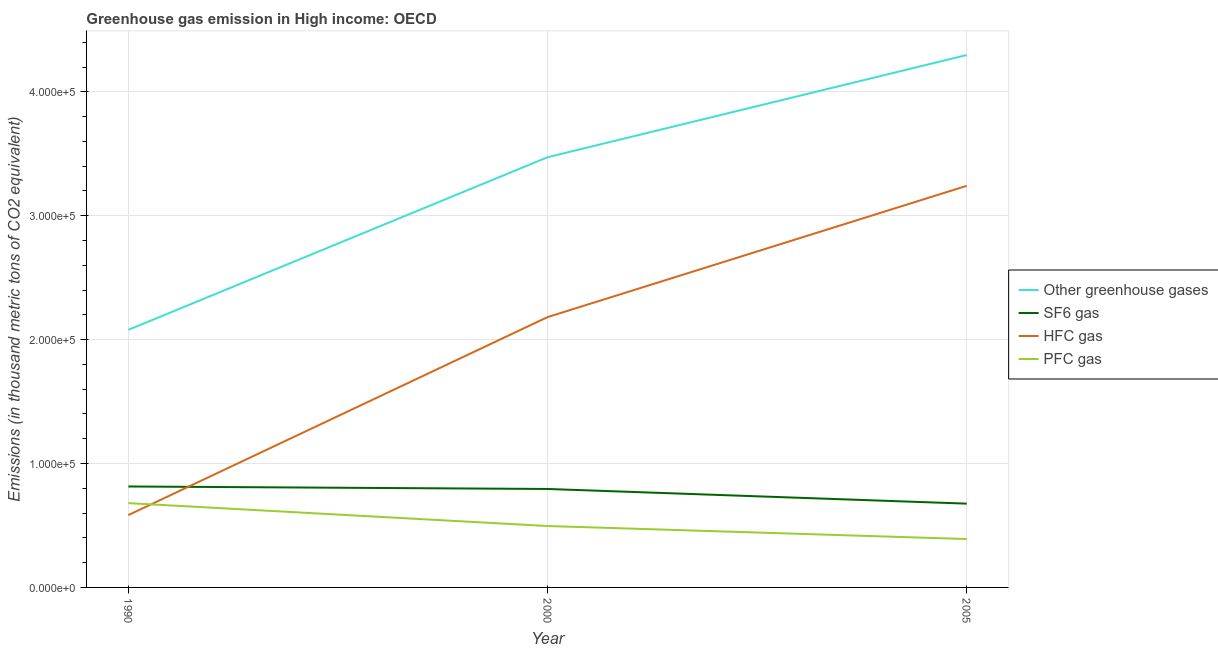What is the emission of hfc gas in 2000?
Your response must be concise. 2.18e+05. Across all years, what is the maximum emission of greenhouse gases?
Offer a terse response. 4.30e+05. Across all years, what is the minimum emission of greenhouse gases?
Provide a succinct answer. 2.08e+05. In which year was the emission of sf6 gas maximum?
Your answer should be compact. 1990. In which year was the emission of hfc gas minimum?
Offer a terse response. 1990. What is the total emission of pfc gas in the graph?
Your answer should be very brief. 1.57e+05. What is the difference between the emission of pfc gas in 1990 and that in 2005?
Your response must be concise. 2.90e+04. What is the difference between the emission of pfc gas in 2000 and the emission of sf6 gas in 2005?
Offer a terse response. -1.80e+04. What is the average emission of sf6 gas per year?
Make the answer very short. 7.62e+04. In the year 2005, what is the difference between the emission of sf6 gas and emission of hfc gas?
Keep it short and to the point. -2.57e+05. In how many years, is the emission of sf6 gas greater than 260000 thousand metric tons?
Offer a very short reply. 0. What is the ratio of the emission of greenhouse gases in 1990 to that in 2000?
Give a very brief answer. 0.6. Is the emission of hfc gas in 1990 less than that in 2000?
Keep it short and to the point. Yes. What is the difference between the highest and the second highest emission of greenhouse gases?
Make the answer very short. 8.25e+04. What is the difference between the highest and the lowest emission of pfc gas?
Offer a very short reply. 2.90e+04. Is the sum of the emission of greenhouse gases in 2000 and 2005 greater than the maximum emission of sf6 gas across all years?
Ensure brevity in your answer.  Yes. Is it the case that in every year, the sum of the emission of greenhouse gases and emission of sf6 gas is greater than the emission of hfc gas?
Offer a terse response. Yes. Does the emission of pfc gas monotonically increase over the years?
Make the answer very short. No. Is the emission of sf6 gas strictly greater than the emission of pfc gas over the years?
Your answer should be compact. Yes. How many lines are there?
Your answer should be compact. 4. How many years are there in the graph?
Provide a short and direct response. 3. What is the difference between two consecutive major ticks on the Y-axis?
Give a very brief answer. 1.00e+05. Are the values on the major ticks of Y-axis written in scientific E-notation?
Your answer should be compact. Yes. Where does the legend appear in the graph?
Provide a succinct answer. Center right. How many legend labels are there?
Provide a short and direct response. 4. What is the title of the graph?
Your response must be concise. Greenhouse gas emission in High income: OECD. Does "Financial sector" appear as one of the legend labels in the graph?
Give a very brief answer. No. What is the label or title of the X-axis?
Your response must be concise. Year. What is the label or title of the Y-axis?
Your answer should be compact. Emissions (in thousand metric tons of CO2 equivalent). What is the Emissions (in thousand metric tons of CO2 equivalent) in Other greenhouse gases in 1990?
Your response must be concise. 2.08e+05. What is the Emissions (in thousand metric tons of CO2 equivalent) of SF6 gas in 1990?
Keep it short and to the point. 8.15e+04. What is the Emissions (in thousand metric tons of CO2 equivalent) of HFC gas in 1990?
Offer a very short reply. 5.84e+04. What is the Emissions (in thousand metric tons of CO2 equivalent) of PFC gas in 1990?
Give a very brief answer. 6.80e+04. What is the Emissions (in thousand metric tons of CO2 equivalent) in Other greenhouse gases in 2000?
Make the answer very short. 3.47e+05. What is the Emissions (in thousand metric tons of CO2 equivalent) in SF6 gas in 2000?
Your response must be concise. 7.95e+04. What is the Emissions (in thousand metric tons of CO2 equivalent) in HFC gas in 2000?
Provide a short and direct response. 2.18e+05. What is the Emissions (in thousand metric tons of CO2 equivalent) in PFC gas in 2000?
Ensure brevity in your answer.  4.96e+04. What is the Emissions (in thousand metric tons of CO2 equivalent) in Other greenhouse gases in 2005?
Keep it short and to the point. 4.30e+05. What is the Emissions (in thousand metric tons of CO2 equivalent) in SF6 gas in 2005?
Provide a succinct answer. 6.76e+04. What is the Emissions (in thousand metric tons of CO2 equivalent) of HFC gas in 2005?
Make the answer very short. 3.24e+05. What is the Emissions (in thousand metric tons of CO2 equivalent) of PFC gas in 2005?
Provide a short and direct response. 3.91e+04. Across all years, what is the maximum Emissions (in thousand metric tons of CO2 equivalent) in Other greenhouse gases?
Your answer should be very brief. 4.30e+05. Across all years, what is the maximum Emissions (in thousand metric tons of CO2 equivalent) in SF6 gas?
Provide a succinct answer. 8.15e+04. Across all years, what is the maximum Emissions (in thousand metric tons of CO2 equivalent) in HFC gas?
Your response must be concise. 3.24e+05. Across all years, what is the maximum Emissions (in thousand metric tons of CO2 equivalent) in PFC gas?
Offer a very short reply. 6.80e+04. Across all years, what is the minimum Emissions (in thousand metric tons of CO2 equivalent) in Other greenhouse gases?
Offer a terse response. 2.08e+05. Across all years, what is the minimum Emissions (in thousand metric tons of CO2 equivalent) of SF6 gas?
Keep it short and to the point. 6.76e+04. Across all years, what is the minimum Emissions (in thousand metric tons of CO2 equivalent) of HFC gas?
Provide a short and direct response. 5.84e+04. Across all years, what is the minimum Emissions (in thousand metric tons of CO2 equivalent) in PFC gas?
Ensure brevity in your answer.  3.91e+04. What is the total Emissions (in thousand metric tons of CO2 equivalent) of Other greenhouse gases in the graph?
Provide a short and direct response. 9.85e+05. What is the total Emissions (in thousand metric tons of CO2 equivalent) of SF6 gas in the graph?
Offer a very short reply. 2.29e+05. What is the total Emissions (in thousand metric tons of CO2 equivalent) of HFC gas in the graph?
Your answer should be very brief. 6.01e+05. What is the total Emissions (in thousand metric tons of CO2 equivalent) of PFC gas in the graph?
Provide a short and direct response. 1.57e+05. What is the difference between the Emissions (in thousand metric tons of CO2 equivalent) of Other greenhouse gases in 1990 and that in 2000?
Offer a terse response. -1.39e+05. What is the difference between the Emissions (in thousand metric tons of CO2 equivalent) in SF6 gas in 1990 and that in 2000?
Provide a short and direct response. 2011.1. What is the difference between the Emissions (in thousand metric tons of CO2 equivalent) in HFC gas in 1990 and that in 2000?
Offer a terse response. -1.60e+05. What is the difference between the Emissions (in thousand metric tons of CO2 equivalent) of PFC gas in 1990 and that in 2000?
Your answer should be very brief. 1.85e+04. What is the difference between the Emissions (in thousand metric tons of CO2 equivalent) in Other greenhouse gases in 1990 and that in 2005?
Provide a succinct answer. -2.22e+05. What is the difference between the Emissions (in thousand metric tons of CO2 equivalent) of SF6 gas in 1990 and that in 2005?
Offer a terse response. 1.39e+04. What is the difference between the Emissions (in thousand metric tons of CO2 equivalent) of HFC gas in 1990 and that in 2005?
Ensure brevity in your answer.  -2.66e+05. What is the difference between the Emissions (in thousand metric tons of CO2 equivalent) of PFC gas in 1990 and that in 2005?
Offer a very short reply. 2.90e+04. What is the difference between the Emissions (in thousand metric tons of CO2 equivalent) of Other greenhouse gases in 2000 and that in 2005?
Your response must be concise. -8.25e+04. What is the difference between the Emissions (in thousand metric tons of CO2 equivalent) of SF6 gas in 2000 and that in 2005?
Offer a very short reply. 1.18e+04. What is the difference between the Emissions (in thousand metric tons of CO2 equivalent) in HFC gas in 2000 and that in 2005?
Offer a very short reply. -1.06e+05. What is the difference between the Emissions (in thousand metric tons of CO2 equivalent) of PFC gas in 2000 and that in 2005?
Provide a short and direct response. 1.05e+04. What is the difference between the Emissions (in thousand metric tons of CO2 equivalent) of Other greenhouse gases in 1990 and the Emissions (in thousand metric tons of CO2 equivalent) of SF6 gas in 2000?
Ensure brevity in your answer.  1.28e+05. What is the difference between the Emissions (in thousand metric tons of CO2 equivalent) in Other greenhouse gases in 1990 and the Emissions (in thousand metric tons of CO2 equivalent) in HFC gas in 2000?
Your response must be concise. -1.03e+04. What is the difference between the Emissions (in thousand metric tons of CO2 equivalent) in Other greenhouse gases in 1990 and the Emissions (in thousand metric tons of CO2 equivalent) in PFC gas in 2000?
Provide a short and direct response. 1.58e+05. What is the difference between the Emissions (in thousand metric tons of CO2 equivalent) of SF6 gas in 1990 and the Emissions (in thousand metric tons of CO2 equivalent) of HFC gas in 2000?
Provide a short and direct response. -1.37e+05. What is the difference between the Emissions (in thousand metric tons of CO2 equivalent) in SF6 gas in 1990 and the Emissions (in thousand metric tons of CO2 equivalent) in PFC gas in 2000?
Provide a succinct answer. 3.19e+04. What is the difference between the Emissions (in thousand metric tons of CO2 equivalent) of HFC gas in 1990 and the Emissions (in thousand metric tons of CO2 equivalent) of PFC gas in 2000?
Give a very brief answer. 8816.3. What is the difference between the Emissions (in thousand metric tons of CO2 equivalent) in Other greenhouse gases in 1990 and the Emissions (in thousand metric tons of CO2 equivalent) in SF6 gas in 2005?
Provide a succinct answer. 1.40e+05. What is the difference between the Emissions (in thousand metric tons of CO2 equivalent) in Other greenhouse gases in 1990 and the Emissions (in thousand metric tons of CO2 equivalent) in HFC gas in 2005?
Make the answer very short. -1.16e+05. What is the difference between the Emissions (in thousand metric tons of CO2 equivalent) in Other greenhouse gases in 1990 and the Emissions (in thousand metric tons of CO2 equivalent) in PFC gas in 2005?
Offer a very short reply. 1.69e+05. What is the difference between the Emissions (in thousand metric tons of CO2 equivalent) in SF6 gas in 1990 and the Emissions (in thousand metric tons of CO2 equivalent) in HFC gas in 2005?
Give a very brief answer. -2.43e+05. What is the difference between the Emissions (in thousand metric tons of CO2 equivalent) of SF6 gas in 1990 and the Emissions (in thousand metric tons of CO2 equivalent) of PFC gas in 2005?
Make the answer very short. 4.24e+04. What is the difference between the Emissions (in thousand metric tons of CO2 equivalent) in HFC gas in 1990 and the Emissions (in thousand metric tons of CO2 equivalent) in PFC gas in 2005?
Give a very brief answer. 1.93e+04. What is the difference between the Emissions (in thousand metric tons of CO2 equivalent) of Other greenhouse gases in 2000 and the Emissions (in thousand metric tons of CO2 equivalent) of SF6 gas in 2005?
Ensure brevity in your answer.  2.80e+05. What is the difference between the Emissions (in thousand metric tons of CO2 equivalent) of Other greenhouse gases in 2000 and the Emissions (in thousand metric tons of CO2 equivalent) of HFC gas in 2005?
Your answer should be very brief. 2.31e+04. What is the difference between the Emissions (in thousand metric tons of CO2 equivalent) in Other greenhouse gases in 2000 and the Emissions (in thousand metric tons of CO2 equivalent) in PFC gas in 2005?
Your response must be concise. 3.08e+05. What is the difference between the Emissions (in thousand metric tons of CO2 equivalent) in SF6 gas in 2000 and the Emissions (in thousand metric tons of CO2 equivalent) in HFC gas in 2005?
Your answer should be very brief. -2.45e+05. What is the difference between the Emissions (in thousand metric tons of CO2 equivalent) of SF6 gas in 2000 and the Emissions (in thousand metric tons of CO2 equivalent) of PFC gas in 2005?
Keep it short and to the point. 4.04e+04. What is the difference between the Emissions (in thousand metric tons of CO2 equivalent) in HFC gas in 2000 and the Emissions (in thousand metric tons of CO2 equivalent) in PFC gas in 2005?
Ensure brevity in your answer.  1.79e+05. What is the average Emissions (in thousand metric tons of CO2 equivalent) of Other greenhouse gases per year?
Ensure brevity in your answer.  3.28e+05. What is the average Emissions (in thousand metric tons of CO2 equivalent) of SF6 gas per year?
Give a very brief answer. 7.62e+04. What is the average Emissions (in thousand metric tons of CO2 equivalent) of HFC gas per year?
Ensure brevity in your answer.  2.00e+05. What is the average Emissions (in thousand metric tons of CO2 equivalent) in PFC gas per year?
Your answer should be very brief. 5.22e+04. In the year 1990, what is the difference between the Emissions (in thousand metric tons of CO2 equivalent) in Other greenhouse gases and Emissions (in thousand metric tons of CO2 equivalent) in SF6 gas?
Offer a very short reply. 1.26e+05. In the year 1990, what is the difference between the Emissions (in thousand metric tons of CO2 equivalent) in Other greenhouse gases and Emissions (in thousand metric tons of CO2 equivalent) in HFC gas?
Your answer should be very brief. 1.50e+05. In the year 1990, what is the difference between the Emissions (in thousand metric tons of CO2 equivalent) of Other greenhouse gases and Emissions (in thousand metric tons of CO2 equivalent) of PFC gas?
Your response must be concise. 1.40e+05. In the year 1990, what is the difference between the Emissions (in thousand metric tons of CO2 equivalent) in SF6 gas and Emissions (in thousand metric tons of CO2 equivalent) in HFC gas?
Offer a very short reply. 2.31e+04. In the year 1990, what is the difference between the Emissions (in thousand metric tons of CO2 equivalent) in SF6 gas and Emissions (in thousand metric tons of CO2 equivalent) in PFC gas?
Offer a terse response. 1.34e+04. In the year 1990, what is the difference between the Emissions (in thousand metric tons of CO2 equivalent) in HFC gas and Emissions (in thousand metric tons of CO2 equivalent) in PFC gas?
Keep it short and to the point. -9648.1. In the year 2000, what is the difference between the Emissions (in thousand metric tons of CO2 equivalent) in Other greenhouse gases and Emissions (in thousand metric tons of CO2 equivalent) in SF6 gas?
Your response must be concise. 2.68e+05. In the year 2000, what is the difference between the Emissions (in thousand metric tons of CO2 equivalent) in Other greenhouse gases and Emissions (in thousand metric tons of CO2 equivalent) in HFC gas?
Offer a very short reply. 1.29e+05. In the year 2000, what is the difference between the Emissions (in thousand metric tons of CO2 equivalent) in Other greenhouse gases and Emissions (in thousand metric tons of CO2 equivalent) in PFC gas?
Offer a very short reply. 2.98e+05. In the year 2000, what is the difference between the Emissions (in thousand metric tons of CO2 equivalent) in SF6 gas and Emissions (in thousand metric tons of CO2 equivalent) in HFC gas?
Your answer should be compact. -1.39e+05. In the year 2000, what is the difference between the Emissions (in thousand metric tons of CO2 equivalent) in SF6 gas and Emissions (in thousand metric tons of CO2 equivalent) in PFC gas?
Your answer should be compact. 2.99e+04. In the year 2000, what is the difference between the Emissions (in thousand metric tons of CO2 equivalent) of HFC gas and Emissions (in thousand metric tons of CO2 equivalent) of PFC gas?
Your answer should be very brief. 1.69e+05. In the year 2005, what is the difference between the Emissions (in thousand metric tons of CO2 equivalent) in Other greenhouse gases and Emissions (in thousand metric tons of CO2 equivalent) in SF6 gas?
Offer a very short reply. 3.62e+05. In the year 2005, what is the difference between the Emissions (in thousand metric tons of CO2 equivalent) in Other greenhouse gases and Emissions (in thousand metric tons of CO2 equivalent) in HFC gas?
Offer a terse response. 1.06e+05. In the year 2005, what is the difference between the Emissions (in thousand metric tons of CO2 equivalent) of Other greenhouse gases and Emissions (in thousand metric tons of CO2 equivalent) of PFC gas?
Provide a short and direct response. 3.91e+05. In the year 2005, what is the difference between the Emissions (in thousand metric tons of CO2 equivalent) of SF6 gas and Emissions (in thousand metric tons of CO2 equivalent) of HFC gas?
Offer a terse response. -2.57e+05. In the year 2005, what is the difference between the Emissions (in thousand metric tons of CO2 equivalent) in SF6 gas and Emissions (in thousand metric tons of CO2 equivalent) in PFC gas?
Provide a succinct answer. 2.86e+04. In the year 2005, what is the difference between the Emissions (in thousand metric tons of CO2 equivalent) of HFC gas and Emissions (in thousand metric tons of CO2 equivalent) of PFC gas?
Keep it short and to the point. 2.85e+05. What is the ratio of the Emissions (in thousand metric tons of CO2 equivalent) in Other greenhouse gases in 1990 to that in 2000?
Ensure brevity in your answer.  0.6. What is the ratio of the Emissions (in thousand metric tons of CO2 equivalent) in SF6 gas in 1990 to that in 2000?
Offer a very short reply. 1.03. What is the ratio of the Emissions (in thousand metric tons of CO2 equivalent) in HFC gas in 1990 to that in 2000?
Provide a succinct answer. 0.27. What is the ratio of the Emissions (in thousand metric tons of CO2 equivalent) of PFC gas in 1990 to that in 2000?
Give a very brief answer. 1.37. What is the ratio of the Emissions (in thousand metric tons of CO2 equivalent) in Other greenhouse gases in 1990 to that in 2005?
Ensure brevity in your answer.  0.48. What is the ratio of the Emissions (in thousand metric tons of CO2 equivalent) in SF6 gas in 1990 to that in 2005?
Your response must be concise. 1.2. What is the ratio of the Emissions (in thousand metric tons of CO2 equivalent) in HFC gas in 1990 to that in 2005?
Your answer should be very brief. 0.18. What is the ratio of the Emissions (in thousand metric tons of CO2 equivalent) in PFC gas in 1990 to that in 2005?
Your answer should be compact. 1.74. What is the ratio of the Emissions (in thousand metric tons of CO2 equivalent) in Other greenhouse gases in 2000 to that in 2005?
Your answer should be very brief. 0.81. What is the ratio of the Emissions (in thousand metric tons of CO2 equivalent) of SF6 gas in 2000 to that in 2005?
Ensure brevity in your answer.  1.18. What is the ratio of the Emissions (in thousand metric tons of CO2 equivalent) of HFC gas in 2000 to that in 2005?
Provide a short and direct response. 0.67. What is the ratio of the Emissions (in thousand metric tons of CO2 equivalent) of PFC gas in 2000 to that in 2005?
Provide a short and direct response. 1.27. What is the difference between the highest and the second highest Emissions (in thousand metric tons of CO2 equivalent) of Other greenhouse gases?
Your answer should be compact. 8.25e+04. What is the difference between the highest and the second highest Emissions (in thousand metric tons of CO2 equivalent) of SF6 gas?
Offer a terse response. 2011.1. What is the difference between the highest and the second highest Emissions (in thousand metric tons of CO2 equivalent) in HFC gas?
Ensure brevity in your answer.  1.06e+05. What is the difference between the highest and the second highest Emissions (in thousand metric tons of CO2 equivalent) of PFC gas?
Offer a very short reply. 1.85e+04. What is the difference between the highest and the lowest Emissions (in thousand metric tons of CO2 equivalent) of Other greenhouse gases?
Offer a terse response. 2.22e+05. What is the difference between the highest and the lowest Emissions (in thousand metric tons of CO2 equivalent) of SF6 gas?
Offer a very short reply. 1.39e+04. What is the difference between the highest and the lowest Emissions (in thousand metric tons of CO2 equivalent) of HFC gas?
Keep it short and to the point. 2.66e+05. What is the difference between the highest and the lowest Emissions (in thousand metric tons of CO2 equivalent) of PFC gas?
Offer a terse response. 2.90e+04. 